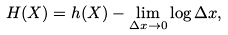<formula> <loc_0><loc_0><loc_500><loc_500>H ( X ) = h ( X ) - \lim _ { \Delta x \rightarrow 0 } \log \Delta x ,</formula> 